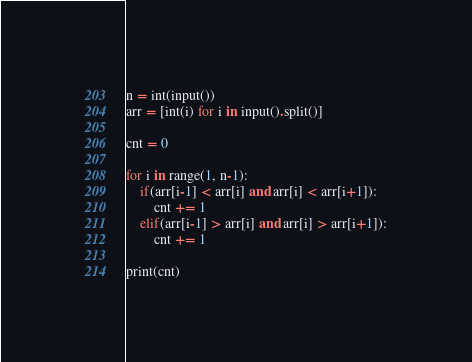Convert code to text. <code><loc_0><loc_0><loc_500><loc_500><_Python_>n = int(input())
arr = [int(i) for i in input().split()]

cnt = 0

for i in range(1, n-1):
    if(arr[i-1] < arr[i] and arr[i] < arr[i+1]):
        cnt += 1
    elif(arr[i-1] > arr[i] and arr[i] > arr[i+1]):
        cnt += 1

print(cnt)</code> 